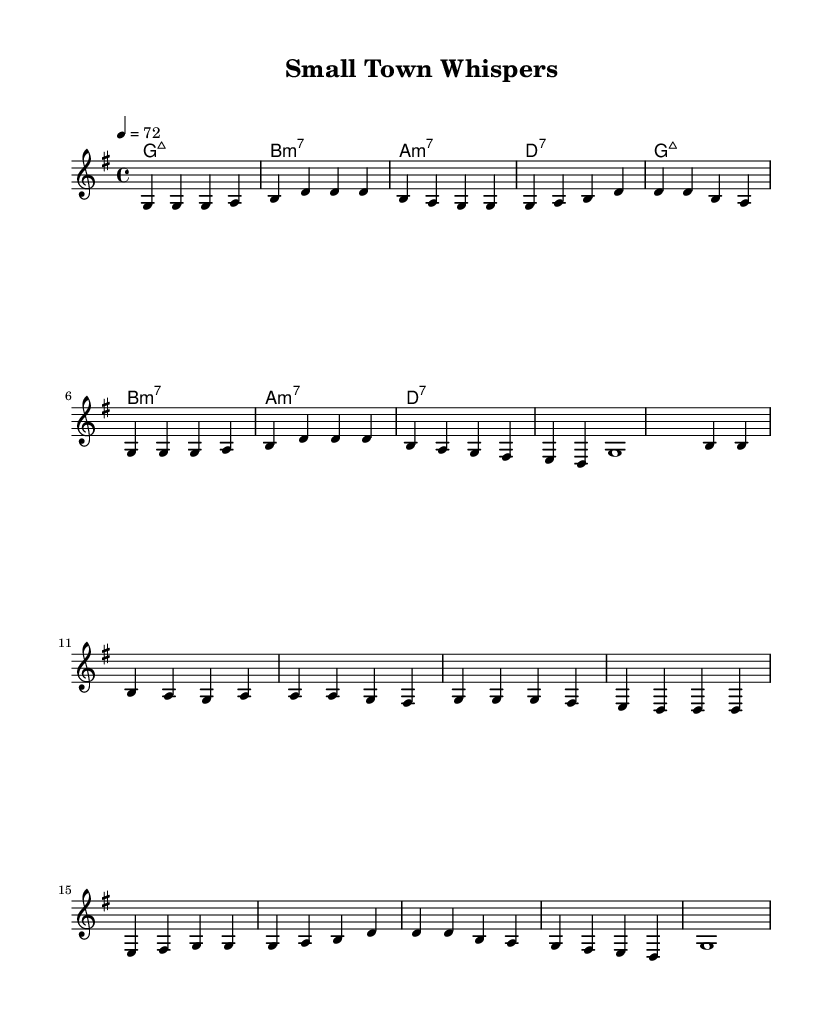What is the key signature of this music? The key signature indicates that the music is in G major, identified by one sharp (F#).
Answer: G major What is the time signature of this music? The time signature shows that the piece is set in 4/4, meaning there are four beats per measure.
Answer: 4/4 What is the tempo marking for this music? The tempo marking indicates that the music should be played at a speed of 72 beats per minute, expressed in quarter notes.
Answer: 72 How many measures are in the verse? By counting the measures in the melody section labeled "Verse," we see there are 8 measures total.
Answer: 8 What is the first chord in the harmony? The first chord presented in the harmony section is G major 7, indicated in the chord symbols.
Answer: G major 7 How does the chorus relate to the verse in structure? The chorus follows a similar melodic structure as the verse but introduces different lyrics, maintaining the same chord progression and rhythm.
Answer: Similar structure What musical style does this piece represent? The piece is characterized as Rhythm and Blues, focusing on smooth grooves and themes of community.
Answer: Rhythm and Blues 